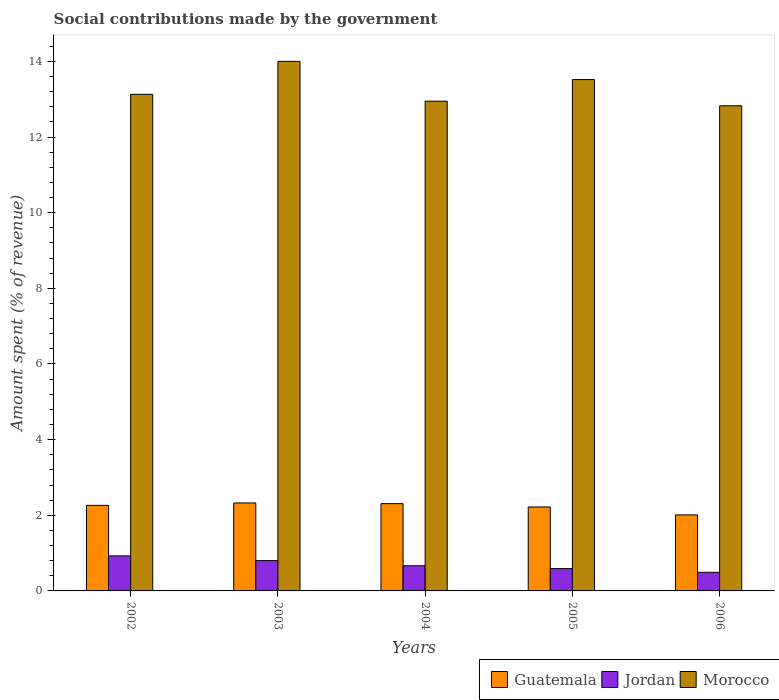How many groups of bars are there?
Ensure brevity in your answer.  5. How many bars are there on the 1st tick from the left?
Your answer should be compact. 3. What is the amount spent (in %) on social contributions in Jordan in 2005?
Provide a succinct answer. 0.59. Across all years, what is the maximum amount spent (in %) on social contributions in Jordan?
Offer a very short reply. 0.93. Across all years, what is the minimum amount spent (in %) on social contributions in Morocco?
Keep it short and to the point. 12.83. In which year was the amount spent (in %) on social contributions in Jordan maximum?
Provide a short and direct response. 2002. What is the total amount spent (in %) on social contributions in Guatemala in the graph?
Ensure brevity in your answer.  11.13. What is the difference between the amount spent (in %) on social contributions in Morocco in 2004 and that in 2005?
Your answer should be very brief. -0.57. What is the difference between the amount spent (in %) on social contributions in Guatemala in 2006 and the amount spent (in %) on social contributions in Morocco in 2004?
Make the answer very short. -10.94. What is the average amount spent (in %) on social contributions in Morocco per year?
Offer a terse response. 13.29. In the year 2003, what is the difference between the amount spent (in %) on social contributions in Jordan and amount spent (in %) on social contributions in Morocco?
Make the answer very short. -13.2. What is the ratio of the amount spent (in %) on social contributions in Guatemala in 2004 to that in 2005?
Provide a succinct answer. 1.04. Is the amount spent (in %) on social contributions in Jordan in 2002 less than that in 2004?
Make the answer very short. No. What is the difference between the highest and the second highest amount spent (in %) on social contributions in Guatemala?
Your response must be concise. 0.02. What is the difference between the highest and the lowest amount spent (in %) on social contributions in Morocco?
Your response must be concise. 1.18. In how many years, is the amount spent (in %) on social contributions in Jordan greater than the average amount spent (in %) on social contributions in Jordan taken over all years?
Offer a very short reply. 2. What does the 1st bar from the left in 2005 represents?
Provide a short and direct response. Guatemala. What does the 1st bar from the right in 2003 represents?
Make the answer very short. Morocco. Is it the case that in every year, the sum of the amount spent (in %) on social contributions in Guatemala and amount spent (in %) on social contributions in Morocco is greater than the amount spent (in %) on social contributions in Jordan?
Make the answer very short. Yes. Are all the bars in the graph horizontal?
Offer a terse response. No. What is the difference between two consecutive major ticks on the Y-axis?
Offer a very short reply. 2. Are the values on the major ticks of Y-axis written in scientific E-notation?
Your response must be concise. No. Does the graph contain any zero values?
Ensure brevity in your answer.  No. Where does the legend appear in the graph?
Offer a terse response. Bottom right. How many legend labels are there?
Ensure brevity in your answer.  3. What is the title of the graph?
Keep it short and to the point. Social contributions made by the government. Does "Trinidad and Tobago" appear as one of the legend labels in the graph?
Offer a terse response. No. What is the label or title of the X-axis?
Give a very brief answer. Years. What is the label or title of the Y-axis?
Your answer should be compact. Amount spent (% of revenue). What is the Amount spent (% of revenue) in Guatemala in 2002?
Offer a terse response. 2.26. What is the Amount spent (% of revenue) of Jordan in 2002?
Your answer should be compact. 0.93. What is the Amount spent (% of revenue) in Morocco in 2002?
Make the answer very short. 13.13. What is the Amount spent (% of revenue) in Guatemala in 2003?
Provide a succinct answer. 2.33. What is the Amount spent (% of revenue) of Jordan in 2003?
Your response must be concise. 0.8. What is the Amount spent (% of revenue) in Morocco in 2003?
Offer a terse response. 14. What is the Amount spent (% of revenue) in Guatemala in 2004?
Ensure brevity in your answer.  2.31. What is the Amount spent (% of revenue) in Jordan in 2004?
Offer a terse response. 0.67. What is the Amount spent (% of revenue) of Morocco in 2004?
Provide a short and direct response. 12.95. What is the Amount spent (% of revenue) in Guatemala in 2005?
Your response must be concise. 2.22. What is the Amount spent (% of revenue) of Jordan in 2005?
Provide a succinct answer. 0.59. What is the Amount spent (% of revenue) of Morocco in 2005?
Provide a short and direct response. 13.52. What is the Amount spent (% of revenue) in Guatemala in 2006?
Ensure brevity in your answer.  2.01. What is the Amount spent (% of revenue) in Jordan in 2006?
Give a very brief answer. 0.49. What is the Amount spent (% of revenue) of Morocco in 2006?
Ensure brevity in your answer.  12.83. Across all years, what is the maximum Amount spent (% of revenue) in Guatemala?
Offer a terse response. 2.33. Across all years, what is the maximum Amount spent (% of revenue) in Jordan?
Offer a terse response. 0.93. Across all years, what is the maximum Amount spent (% of revenue) in Morocco?
Your answer should be compact. 14. Across all years, what is the minimum Amount spent (% of revenue) in Guatemala?
Your answer should be very brief. 2.01. Across all years, what is the minimum Amount spent (% of revenue) of Jordan?
Your response must be concise. 0.49. Across all years, what is the minimum Amount spent (% of revenue) of Morocco?
Ensure brevity in your answer.  12.83. What is the total Amount spent (% of revenue) of Guatemala in the graph?
Ensure brevity in your answer.  11.13. What is the total Amount spent (% of revenue) of Jordan in the graph?
Offer a terse response. 3.48. What is the total Amount spent (% of revenue) in Morocco in the graph?
Offer a terse response. 66.43. What is the difference between the Amount spent (% of revenue) in Guatemala in 2002 and that in 2003?
Your answer should be very brief. -0.06. What is the difference between the Amount spent (% of revenue) in Jordan in 2002 and that in 2003?
Your answer should be compact. 0.12. What is the difference between the Amount spent (% of revenue) in Morocco in 2002 and that in 2003?
Offer a terse response. -0.87. What is the difference between the Amount spent (% of revenue) of Guatemala in 2002 and that in 2004?
Make the answer very short. -0.05. What is the difference between the Amount spent (% of revenue) of Jordan in 2002 and that in 2004?
Provide a succinct answer. 0.26. What is the difference between the Amount spent (% of revenue) of Morocco in 2002 and that in 2004?
Keep it short and to the point. 0.18. What is the difference between the Amount spent (% of revenue) in Guatemala in 2002 and that in 2005?
Give a very brief answer. 0.04. What is the difference between the Amount spent (% of revenue) of Jordan in 2002 and that in 2005?
Keep it short and to the point. 0.34. What is the difference between the Amount spent (% of revenue) in Morocco in 2002 and that in 2005?
Ensure brevity in your answer.  -0.39. What is the difference between the Amount spent (% of revenue) in Guatemala in 2002 and that in 2006?
Provide a short and direct response. 0.25. What is the difference between the Amount spent (% of revenue) in Jordan in 2002 and that in 2006?
Keep it short and to the point. 0.43. What is the difference between the Amount spent (% of revenue) in Morocco in 2002 and that in 2006?
Offer a terse response. 0.3. What is the difference between the Amount spent (% of revenue) of Guatemala in 2003 and that in 2004?
Ensure brevity in your answer.  0.02. What is the difference between the Amount spent (% of revenue) in Jordan in 2003 and that in 2004?
Offer a very short reply. 0.14. What is the difference between the Amount spent (% of revenue) of Morocco in 2003 and that in 2004?
Offer a very short reply. 1.05. What is the difference between the Amount spent (% of revenue) of Guatemala in 2003 and that in 2005?
Your response must be concise. 0.11. What is the difference between the Amount spent (% of revenue) of Jordan in 2003 and that in 2005?
Offer a very short reply. 0.21. What is the difference between the Amount spent (% of revenue) of Morocco in 2003 and that in 2005?
Provide a short and direct response. 0.48. What is the difference between the Amount spent (% of revenue) of Guatemala in 2003 and that in 2006?
Offer a terse response. 0.32. What is the difference between the Amount spent (% of revenue) in Jordan in 2003 and that in 2006?
Keep it short and to the point. 0.31. What is the difference between the Amount spent (% of revenue) of Morocco in 2003 and that in 2006?
Offer a very short reply. 1.18. What is the difference between the Amount spent (% of revenue) of Guatemala in 2004 and that in 2005?
Your answer should be compact. 0.09. What is the difference between the Amount spent (% of revenue) of Jordan in 2004 and that in 2005?
Provide a short and direct response. 0.07. What is the difference between the Amount spent (% of revenue) in Morocco in 2004 and that in 2005?
Ensure brevity in your answer.  -0.57. What is the difference between the Amount spent (% of revenue) of Guatemala in 2004 and that in 2006?
Offer a very short reply. 0.3. What is the difference between the Amount spent (% of revenue) of Jordan in 2004 and that in 2006?
Your response must be concise. 0.17. What is the difference between the Amount spent (% of revenue) of Morocco in 2004 and that in 2006?
Ensure brevity in your answer.  0.12. What is the difference between the Amount spent (% of revenue) in Guatemala in 2005 and that in 2006?
Give a very brief answer. 0.21. What is the difference between the Amount spent (% of revenue) of Jordan in 2005 and that in 2006?
Ensure brevity in your answer.  0.1. What is the difference between the Amount spent (% of revenue) of Morocco in 2005 and that in 2006?
Offer a terse response. 0.69. What is the difference between the Amount spent (% of revenue) in Guatemala in 2002 and the Amount spent (% of revenue) in Jordan in 2003?
Offer a very short reply. 1.46. What is the difference between the Amount spent (% of revenue) in Guatemala in 2002 and the Amount spent (% of revenue) in Morocco in 2003?
Offer a very short reply. -11.74. What is the difference between the Amount spent (% of revenue) in Jordan in 2002 and the Amount spent (% of revenue) in Morocco in 2003?
Give a very brief answer. -13.08. What is the difference between the Amount spent (% of revenue) of Guatemala in 2002 and the Amount spent (% of revenue) of Jordan in 2004?
Provide a short and direct response. 1.6. What is the difference between the Amount spent (% of revenue) of Guatemala in 2002 and the Amount spent (% of revenue) of Morocco in 2004?
Your answer should be very brief. -10.69. What is the difference between the Amount spent (% of revenue) of Jordan in 2002 and the Amount spent (% of revenue) of Morocco in 2004?
Make the answer very short. -12.02. What is the difference between the Amount spent (% of revenue) of Guatemala in 2002 and the Amount spent (% of revenue) of Jordan in 2005?
Offer a terse response. 1.67. What is the difference between the Amount spent (% of revenue) in Guatemala in 2002 and the Amount spent (% of revenue) in Morocco in 2005?
Keep it short and to the point. -11.26. What is the difference between the Amount spent (% of revenue) of Jordan in 2002 and the Amount spent (% of revenue) of Morocco in 2005?
Your answer should be very brief. -12.59. What is the difference between the Amount spent (% of revenue) of Guatemala in 2002 and the Amount spent (% of revenue) of Jordan in 2006?
Make the answer very short. 1.77. What is the difference between the Amount spent (% of revenue) of Guatemala in 2002 and the Amount spent (% of revenue) of Morocco in 2006?
Offer a very short reply. -10.56. What is the difference between the Amount spent (% of revenue) of Jordan in 2002 and the Amount spent (% of revenue) of Morocco in 2006?
Ensure brevity in your answer.  -11.9. What is the difference between the Amount spent (% of revenue) in Guatemala in 2003 and the Amount spent (% of revenue) in Jordan in 2004?
Your answer should be very brief. 1.66. What is the difference between the Amount spent (% of revenue) of Guatemala in 2003 and the Amount spent (% of revenue) of Morocco in 2004?
Offer a terse response. -10.62. What is the difference between the Amount spent (% of revenue) of Jordan in 2003 and the Amount spent (% of revenue) of Morocco in 2004?
Keep it short and to the point. -12.15. What is the difference between the Amount spent (% of revenue) in Guatemala in 2003 and the Amount spent (% of revenue) in Jordan in 2005?
Your response must be concise. 1.74. What is the difference between the Amount spent (% of revenue) in Guatemala in 2003 and the Amount spent (% of revenue) in Morocco in 2005?
Give a very brief answer. -11.19. What is the difference between the Amount spent (% of revenue) of Jordan in 2003 and the Amount spent (% of revenue) of Morocco in 2005?
Ensure brevity in your answer.  -12.72. What is the difference between the Amount spent (% of revenue) in Guatemala in 2003 and the Amount spent (% of revenue) in Jordan in 2006?
Ensure brevity in your answer.  1.83. What is the difference between the Amount spent (% of revenue) of Guatemala in 2003 and the Amount spent (% of revenue) of Morocco in 2006?
Offer a very short reply. -10.5. What is the difference between the Amount spent (% of revenue) in Jordan in 2003 and the Amount spent (% of revenue) in Morocco in 2006?
Your answer should be compact. -12.02. What is the difference between the Amount spent (% of revenue) of Guatemala in 2004 and the Amount spent (% of revenue) of Jordan in 2005?
Offer a terse response. 1.72. What is the difference between the Amount spent (% of revenue) in Guatemala in 2004 and the Amount spent (% of revenue) in Morocco in 2005?
Offer a terse response. -11.21. What is the difference between the Amount spent (% of revenue) of Jordan in 2004 and the Amount spent (% of revenue) of Morocco in 2005?
Your answer should be very brief. -12.85. What is the difference between the Amount spent (% of revenue) of Guatemala in 2004 and the Amount spent (% of revenue) of Jordan in 2006?
Your response must be concise. 1.81. What is the difference between the Amount spent (% of revenue) of Guatemala in 2004 and the Amount spent (% of revenue) of Morocco in 2006?
Offer a terse response. -10.52. What is the difference between the Amount spent (% of revenue) in Jordan in 2004 and the Amount spent (% of revenue) in Morocco in 2006?
Your answer should be very brief. -12.16. What is the difference between the Amount spent (% of revenue) in Guatemala in 2005 and the Amount spent (% of revenue) in Jordan in 2006?
Keep it short and to the point. 1.73. What is the difference between the Amount spent (% of revenue) of Guatemala in 2005 and the Amount spent (% of revenue) of Morocco in 2006?
Your response must be concise. -10.61. What is the difference between the Amount spent (% of revenue) of Jordan in 2005 and the Amount spent (% of revenue) of Morocco in 2006?
Provide a short and direct response. -12.24. What is the average Amount spent (% of revenue) of Guatemala per year?
Provide a succinct answer. 2.23. What is the average Amount spent (% of revenue) of Jordan per year?
Provide a short and direct response. 0.7. What is the average Amount spent (% of revenue) in Morocco per year?
Your answer should be very brief. 13.29. In the year 2002, what is the difference between the Amount spent (% of revenue) in Guatemala and Amount spent (% of revenue) in Jordan?
Provide a short and direct response. 1.34. In the year 2002, what is the difference between the Amount spent (% of revenue) in Guatemala and Amount spent (% of revenue) in Morocco?
Offer a terse response. -10.87. In the year 2002, what is the difference between the Amount spent (% of revenue) of Jordan and Amount spent (% of revenue) of Morocco?
Ensure brevity in your answer.  -12.2. In the year 2003, what is the difference between the Amount spent (% of revenue) in Guatemala and Amount spent (% of revenue) in Jordan?
Provide a short and direct response. 1.52. In the year 2003, what is the difference between the Amount spent (% of revenue) of Guatemala and Amount spent (% of revenue) of Morocco?
Provide a succinct answer. -11.68. In the year 2003, what is the difference between the Amount spent (% of revenue) of Jordan and Amount spent (% of revenue) of Morocco?
Make the answer very short. -13.2. In the year 2004, what is the difference between the Amount spent (% of revenue) in Guatemala and Amount spent (% of revenue) in Jordan?
Your answer should be compact. 1.64. In the year 2004, what is the difference between the Amount spent (% of revenue) of Guatemala and Amount spent (% of revenue) of Morocco?
Offer a terse response. -10.64. In the year 2004, what is the difference between the Amount spent (% of revenue) in Jordan and Amount spent (% of revenue) in Morocco?
Provide a short and direct response. -12.28. In the year 2005, what is the difference between the Amount spent (% of revenue) in Guatemala and Amount spent (% of revenue) in Jordan?
Make the answer very short. 1.63. In the year 2005, what is the difference between the Amount spent (% of revenue) of Guatemala and Amount spent (% of revenue) of Morocco?
Your answer should be very brief. -11.3. In the year 2005, what is the difference between the Amount spent (% of revenue) in Jordan and Amount spent (% of revenue) in Morocco?
Your answer should be compact. -12.93. In the year 2006, what is the difference between the Amount spent (% of revenue) in Guatemala and Amount spent (% of revenue) in Jordan?
Provide a short and direct response. 1.52. In the year 2006, what is the difference between the Amount spent (% of revenue) of Guatemala and Amount spent (% of revenue) of Morocco?
Ensure brevity in your answer.  -10.82. In the year 2006, what is the difference between the Amount spent (% of revenue) of Jordan and Amount spent (% of revenue) of Morocco?
Keep it short and to the point. -12.33. What is the ratio of the Amount spent (% of revenue) of Guatemala in 2002 to that in 2003?
Ensure brevity in your answer.  0.97. What is the ratio of the Amount spent (% of revenue) in Jordan in 2002 to that in 2003?
Your answer should be compact. 1.16. What is the ratio of the Amount spent (% of revenue) in Morocco in 2002 to that in 2003?
Give a very brief answer. 0.94. What is the ratio of the Amount spent (% of revenue) of Guatemala in 2002 to that in 2004?
Your answer should be very brief. 0.98. What is the ratio of the Amount spent (% of revenue) in Jordan in 2002 to that in 2004?
Provide a succinct answer. 1.39. What is the ratio of the Amount spent (% of revenue) in Morocco in 2002 to that in 2004?
Give a very brief answer. 1.01. What is the ratio of the Amount spent (% of revenue) of Guatemala in 2002 to that in 2005?
Provide a short and direct response. 1.02. What is the ratio of the Amount spent (% of revenue) in Jordan in 2002 to that in 2005?
Offer a very short reply. 1.57. What is the ratio of the Amount spent (% of revenue) in Morocco in 2002 to that in 2005?
Provide a succinct answer. 0.97. What is the ratio of the Amount spent (% of revenue) of Guatemala in 2002 to that in 2006?
Your response must be concise. 1.13. What is the ratio of the Amount spent (% of revenue) of Jordan in 2002 to that in 2006?
Offer a very short reply. 1.88. What is the ratio of the Amount spent (% of revenue) in Morocco in 2002 to that in 2006?
Provide a short and direct response. 1.02. What is the ratio of the Amount spent (% of revenue) in Guatemala in 2003 to that in 2004?
Give a very brief answer. 1.01. What is the ratio of the Amount spent (% of revenue) in Jordan in 2003 to that in 2004?
Your answer should be very brief. 1.21. What is the ratio of the Amount spent (% of revenue) of Morocco in 2003 to that in 2004?
Offer a very short reply. 1.08. What is the ratio of the Amount spent (% of revenue) of Guatemala in 2003 to that in 2005?
Offer a terse response. 1.05. What is the ratio of the Amount spent (% of revenue) of Jordan in 2003 to that in 2005?
Keep it short and to the point. 1.36. What is the ratio of the Amount spent (% of revenue) of Morocco in 2003 to that in 2005?
Your answer should be compact. 1.04. What is the ratio of the Amount spent (% of revenue) in Guatemala in 2003 to that in 2006?
Keep it short and to the point. 1.16. What is the ratio of the Amount spent (% of revenue) of Jordan in 2003 to that in 2006?
Keep it short and to the point. 1.63. What is the ratio of the Amount spent (% of revenue) of Morocco in 2003 to that in 2006?
Provide a succinct answer. 1.09. What is the ratio of the Amount spent (% of revenue) in Guatemala in 2004 to that in 2005?
Offer a terse response. 1.04. What is the ratio of the Amount spent (% of revenue) in Jordan in 2004 to that in 2005?
Offer a very short reply. 1.13. What is the ratio of the Amount spent (% of revenue) in Morocco in 2004 to that in 2005?
Provide a succinct answer. 0.96. What is the ratio of the Amount spent (% of revenue) in Guatemala in 2004 to that in 2006?
Your answer should be very brief. 1.15. What is the ratio of the Amount spent (% of revenue) of Jordan in 2004 to that in 2006?
Ensure brevity in your answer.  1.35. What is the ratio of the Amount spent (% of revenue) in Morocco in 2004 to that in 2006?
Give a very brief answer. 1.01. What is the ratio of the Amount spent (% of revenue) in Guatemala in 2005 to that in 2006?
Your answer should be very brief. 1.1. What is the ratio of the Amount spent (% of revenue) in Jordan in 2005 to that in 2006?
Make the answer very short. 1.2. What is the ratio of the Amount spent (% of revenue) in Morocco in 2005 to that in 2006?
Make the answer very short. 1.05. What is the difference between the highest and the second highest Amount spent (% of revenue) in Guatemala?
Your answer should be very brief. 0.02. What is the difference between the highest and the second highest Amount spent (% of revenue) in Jordan?
Your answer should be compact. 0.12. What is the difference between the highest and the second highest Amount spent (% of revenue) of Morocco?
Provide a short and direct response. 0.48. What is the difference between the highest and the lowest Amount spent (% of revenue) in Guatemala?
Provide a short and direct response. 0.32. What is the difference between the highest and the lowest Amount spent (% of revenue) of Jordan?
Your answer should be very brief. 0.43. What is the difference between the highest and the lowest Amount spent (% of revenue) in Morocco?
Offer a very short reply. 1.18. 